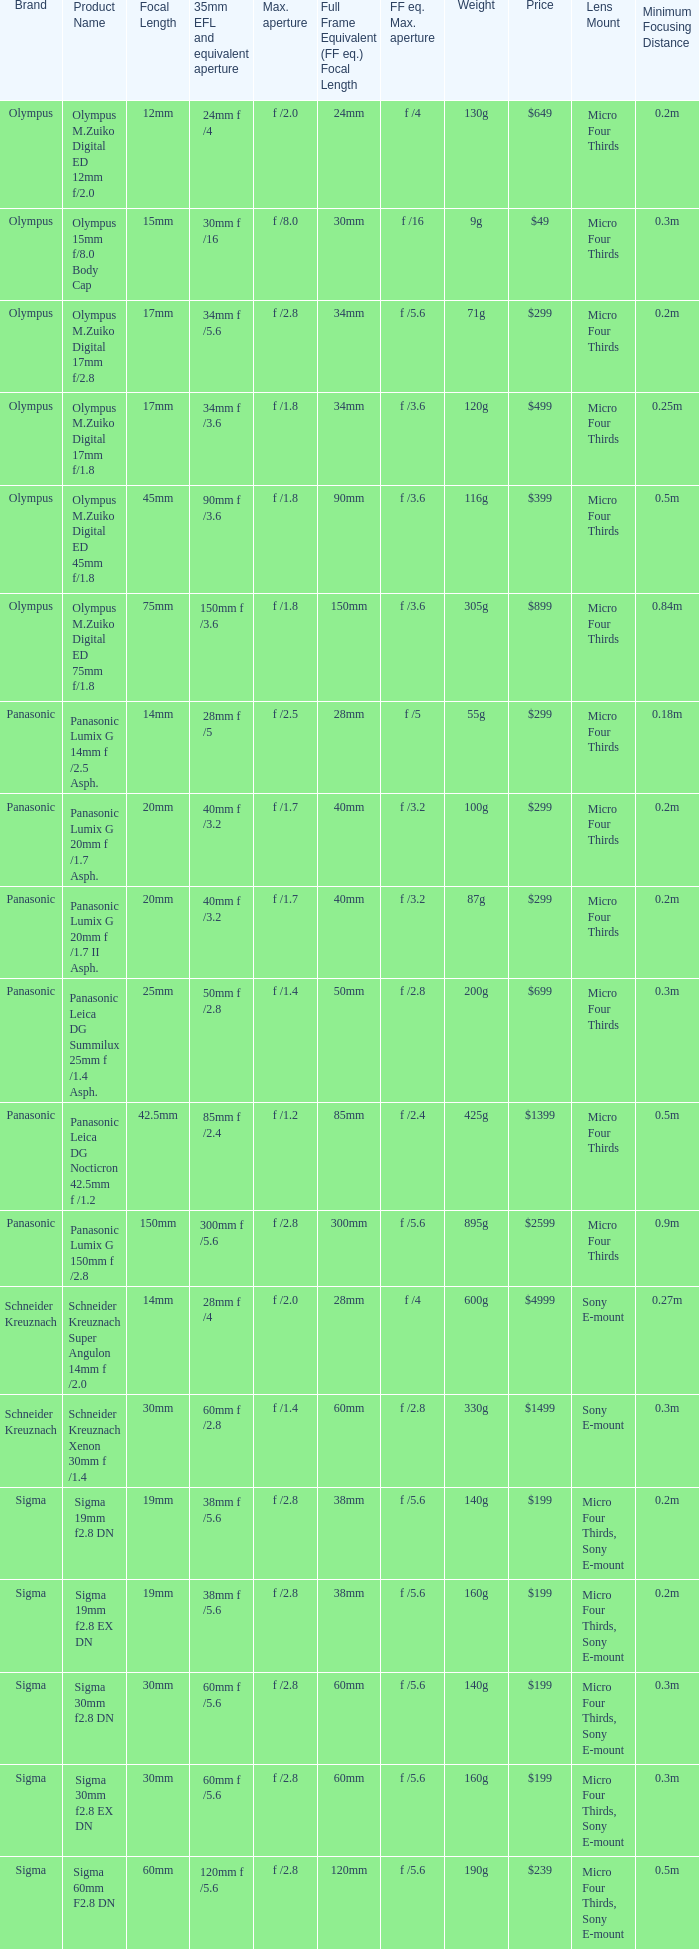What is the maximum aperture of the lens(es) with a focal length of 20mm? F /1.7, f /1.7. 